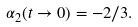Convert formula to latex. <formula><loc_0><loc_0><loc_500><loc_500>\alpha _ { 2 } ( t \to 0 ) = - 2 / 3 .</formula> 